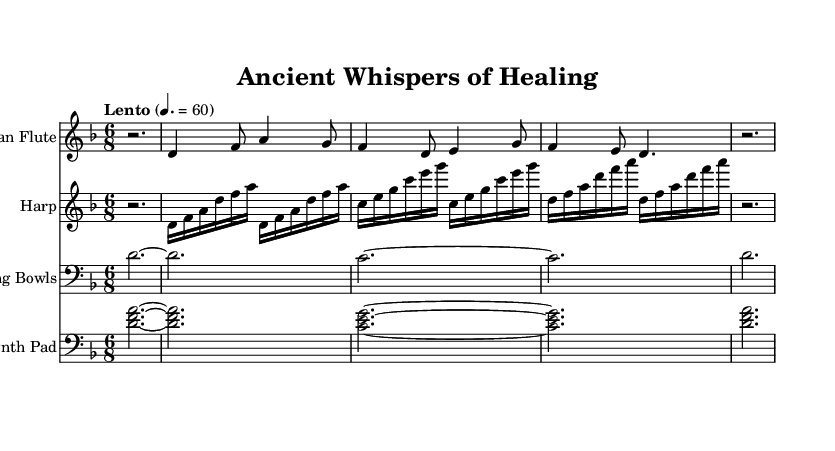What is the key signature of this music? The key signature is D minor, which has one flat (B flat).
Answer: D minor What is the time signature of this music? The time signature is 6/8, indicating six eighth notes per measure.
Answer: 6/8 What is the tempo marking for this piece? The tempo marking is "Lento," which indicates a slow pace, specifically a broad and leisurely tempo (around 60 beats per minute).
Answer: Lento How many measures are there in the flute music part? There are a total of 4 measures in the flute music part as indicated by the spacing and the printed notes.
Answer: 4 How does the harp music differ in rhythmic complexity compared to the flute music? The harp music consists primarily of repeated sixteenth notes, creating a more intricate texture, while the flute music features a simpler rhythmic pattern.
Answer: More intricate What is the instrument used for the singing bowls part? The singing bowls part is played with traditional singing bowls, which produce a resonant sound that adds to the mystical quality of the soundtrack.
Answer: Singing bowls What chords are used in the synth pad section? The synth pad section uses the chords D minor and C major, as shown by the vertical alignment of the notes.
Answer: D minor and C major 